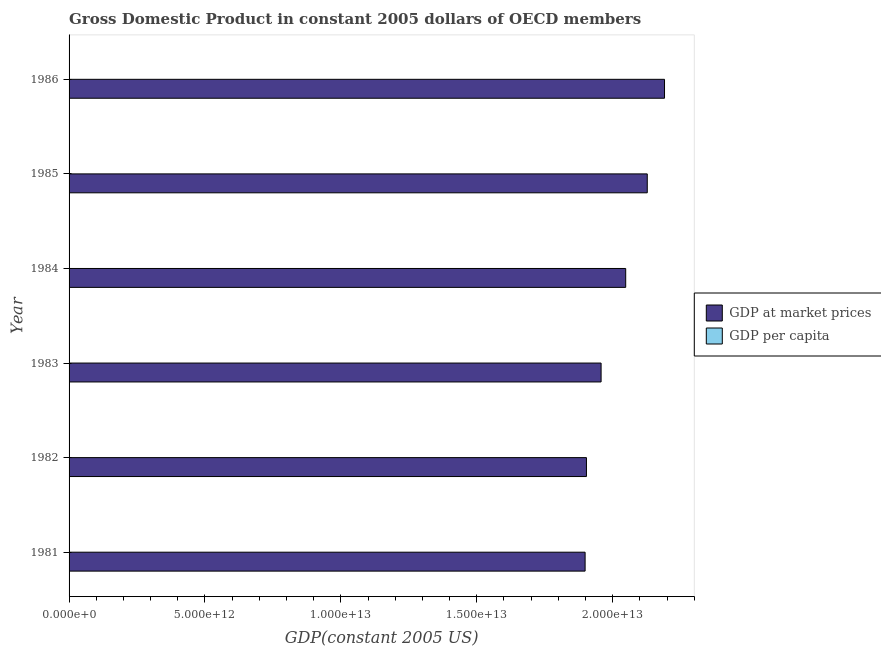How many different coloured bars are there?
Offer a terse response. 2. How many bars are there on the 2nd tick from the bottom?
Ensure brevity in your answer.  2. What is the label of the 3rd group of bars from the top?
Provide a succinct answer. 1984. What is the gdp at market prices in 1982?
Make the answer very short. 1.90e+13. Across all years, what is the maximum gdp at market prices?
Your answer should be compact. 2.19e+13. Across all years, what is the minimum gdp per capita?
Offer a very short reply. 1.90e+04. In which year was the gdp per capita minimum?
Your answer should be very brief. 1982. What is the total gdp per capita in the graph?
Keep it short and to the point. 1.20e+05. What is the difference between the gdp per capita in 1981 and that in 1985?
Offer a very short reply. -1648.86. What is the difference between the gdp at market prices in 1985 and the gdp per capita in 1982?
Give a very brief answer. 2.13e+13. What is the average gdp at market prices per year?
Give a very brief answer. 2.02e+13. In the year 1983, what is the difference between the gdp per capita and gdp at market prices?
Make the answer very short. -1.96e+13. What is the ratio of the gdp at market prices in 1982 to that in 1984?
Provide a short and direct response. 0.93. What is the difference between the highest and the second highest gdp per capita?
Make the answer very short. 455.47. What is the difference between the highest and the lowest gdp at market prices?
Keep it short and to the point. 2.92e+12. In how many years, is the gdp per capita greater than the average gdp per capita taken over all years?
Give a very brief answer. 3. What does the 1st bar from the top in 1981 represents?
Offer a very short reply. GDP per capita. What does the 2nd bar from the bottom in 1983 represents?
Make the answer very short. GDP per capita. Are all the bars in the graph horizontal?
Make the answer very short. Yes. How many years are there in the graph?
Provide a short and direct response. 6. What is the difference between two consecutive major ticks on the X-axis?
Give a very brief answer. 5.00e+12. Are the values on the major ticks of X-axis written in scientific E-notation?
Your answer should be compact. Yes. How are the legend labels stacked?
Make the answer very short. Vertical. What is the title of the graph?
Keep it short and to the point. Gross Domestic Product in constant 2005 dollars of OECD members. What is the label or title of the X-axis?
Your response must be concise. GDP(constant 2005 US). What is the label or title of the Y-axis?
Make the answer very short. Year. What is the GDP(constant 2005 US) of GDP at market prices in 1981?
Provide a succinct answer. 1.90e+13. What is the GDP(constant 2005 US) of GDP per capita in 1981?
Your answer should be compact. 1.91e+04. What is the GDP(constant 2005 US) of GDP at market prices in 1982?
Keep it short and to the point. 1.90e+13. What is the GDP(constant 2005 US) in GDP per capita in 1982?
Keep it short and to the point. 1.90e+04. What is the GDP(constant 2005 US) of GDP at market prices in 1983?
Your response must be concise. 1.96e+13. What is the GDP(constant 2005 US) of GDP per capita in 1983?
Provide a short and direct response. 1.94e+04. What is the GDP(constant 2005 US) of GDP at market prices in 1984?
Ensure brevity in your answer.  2.05e+13. What is the GDP(constant 2005 US) in GDP per capita in 1984?
Your answer should be compact. 2.01e+04. What is the GDP(constant 2005 US) of GDP at market prices in 1985?
Offer a terse response. 2.13e+13. What is the GDP(constant 2005 US) of GDP per capita in 1985?
Your answer should be compact. 2.08e+04. What is the GDP(constant 2005 US) in GDP at market prices in 1986?
Make the answer very short. 2.19e+13. What is the GDP(constant 2005 US) in GDP per capita in 1986?
Provide a short and direct response. 2.12e+04. Across all years, what is the maximum GDP(constant 2005 US) in GDP at market prices?
Provide a succinct answer. 2.19e+13. Across all years, what is the maximum GDP(constant 2005 US) of GDP per capita?
Provide a short and direct response. 2.12e+04. Across all years, what is the minimum GDP(constant 2005 US) in GDP at market prices?
Your answer should be compact. 1.90e+13. Across all years, what is the minimum GDP(constant 2005 US) in GDP per capita?
Provide a succinct answer. 1.90e+04. What is the total GDP(constant 2005 US) of GDP at market prices in the graph?
Your answer should be very brief. 1.21e+14. What is the total GDP(constant 2005 US) of GDP per capita in the graph?
Give a very brief answer. 1.20e+05. What is the difference between the GDP(constant 2005 US) of GDP at market prices in 1981 and that in 1982?
Your answer should be compact. -4.97e+1. What is the difference between the GDP(constant 2005 US) in GDP per capita in 1981 and that in 1982?
Your answer should be very brief. 106.9. What is the difference between the GDP(constant 2005 US) of GDP at market prices in 1981 and that in 1983?
Provide a succinct answer. -5.88e+11. What is the difference between the GDP(constant 2005 US) of GDP per capita in 1981 and that in 1983?
Give a very brief answer. -278.28. What is the difference between the GDP(constant 2005 US) of GDP at market prices in 1981 and that in 1984?
Ensure brevity in your answer.  -1.49e+12. What is the difference between the GDP(constant 2005 US) in GDP per capita in 1981 and that in 1984?
Provide a short and direct response. -1024.64. What is the difference between the GDP(constant 2005 US) in GDP at market prices in 1981 and that in 1985?
Offer a very short reply. -2.29e+12. What is the difference between the GDP(constant 2005 US) of GDP per capita in 1981 and that in 1985?
Provide a short and direct response. -1648.85. What is the difference between the GDP(constant 2005 US) in GDP at market prices in 1981 and that in 1986?
Give a very brief answer. -2.92e+12. What is the difference between the GDP(constant 2005 US) of GDP per capita in 1981 and that in 1986?
Your answer should be compact. -2104.33. What is the difference between the GDP(constant 2005 US) of GDP at market prices in 1982 and that in 1983?
Provide a succinct answer. -5.38e+11. What is the difference between the GDP(constant 2005 US) of GDP per capita in 1982 and that in 1983?
Offer a very short reply. -385.18. What is the difference between the GDP(constant 2005 US) in GDP at market prices in 1982 and that in 1984?
Offer a terse response. -1.44e+12. What is the difference between the GDP(constant 2005 US) in GDP per capita in 1982 and that in 1984?
Ensure brevity in your answer.  -1131.54. What is the difference between the GDP(constant 2005 US) of GDP at market prices in 1982 and that in 1985?
Your answer should be very brief. -2.24e+12. What is the difference between the GDP(constant 2005 US) of GDP per capita in 1982 and that in 1985?
Your response must be concise. -1755.76. What is the difference between the GDP(constant 2005 US) of GDP at market prices in 1982 and that in 1986?
Offer a terse response. -2.87e+12. What is the difference between the GDP(constant 2005 US) of GDP per capita in 1982 and that in 1986?
Make the answer very short. -2211.23. What is the difference between the GDP(constant 2005 US) in GDP at market prices in 1983 and that in 1984?
Provide a succinct answer. -9.05e+11. What is the difference between the GDP(constant 2005 US) in GDP per capita in 1983 and that in 1984?
Your answer should be very brief. -746.36. What is the difference between the GDP(constant 2005 US) of GDP at market prices in 1983 and that in 1985?
Give a very brief answer. -1.70e+12. What is the difference between the GDP(constant 2005 US) in GDP per capita in 1983 and that in 1985?
Your response must be concise. -1370.58. What is the difference between the GDP(constant 2005 US) of GDP at market prices in 1983 and that in 1986?
Ensure brevity in your answer.  -2.33e+12. What is the difference between the GDP(constant 2005 US) of GDP per capita in 1983 and that in 1986?
Your answer should be very brief. -1826.05. What is the difference between the GDP(constant 2005 US) of GDP at market prices in 1984 and that in 1985?
Offer a very short reply. -7.93e+11. What is the difference between the GDP(constant 2005 US) in GDP per capita in 1984 and that in 1985?
Provide a short and direct response. -624.22. What is the difference between the GDP(constant 2005 US) in GDP at market prices in 1984 and that in 1986?
Provide a succinct answer. -1.43e+12. What is the difference between the GDP(constant 2005 US) of GDP per capita in 1984 and that in 1986?
Provide a succinct answer. -1079.69. What is the difference between the GDP(constant 2005 US) in GDP at market prices in 1985 and that in 1986?
Make the answer very short. -6.35e+11. What is the difference between the GDP(constant 2005 US) of GDP per capita in 1985 and that in 1986?
Provide a short and direct response. -455.47. What is the difference between the GDP(constant 2005 US) of GDP at market prices in 1981 and the GDP(constant 2005 US) of GDP per capita in 1982?
Provide a succinct answer. 1.90e+13. What is the difference between the GDP(constant 2005 US) in GDP at market prices in 1981 and the GDP(constant 2005 US) in GDP per capita in 1983?
Give a very brief answer. 1.90e+13. What is the difference between the GDP(constant 2005 US) of GDP at market prices in 1981 and the GDP(constant 2005 US) of GDP per capita in 1984?
Provide a succinct answer. 1.90e+13. What is the difference between the GDP(constant 2005 US) in GDP at market prices in 1981 and the GDP(constant 2005 US) in GDP per capita in 1985?
Your response must be concise. 1.90e+13. What is the difference between the GDP(constant 2005 US) in GDP at market prices in 1981 and the GDP(constant 2005 US) in GDP per capita in 1986?
Your response must be concise. 1.90e+13. What is the difference between the GDP(constant 2005 US) in GDP at market prices in 1982 and the GDP(constant 2005 US) in GDP per capita in 1983?
Provide a short and direct response. 1.90e+13. What is the difference between the GDP(constant 2005 US) of GDP at market prices in 1982 and the GDP(constant 2005 US) of GDP per capita in 1984?
Give a very brief answer. 1.90e+13. What is the difference between the GDP(constant 2005 US) of GDP at market prices in 1982 and the GDP(constant 2005 US) of GDP per capita in 1985?
Keep it short and to the point. 1.90e+13. What is the difference between the GDP(constant 2005 US) in GDP at market prices in 1982 and the GDP(constant 2005 US) in GDP per capita in 1986?
Keep it short and to the point. 1.90e+13. What is the difference between the GDP(constant 2005 US) in GDP at market prices in 1983 and the GDP(constant 2005 US) in GDP per capita in 1984?
Your response must be concise. 1.96e+13. What is the difference between the GDP(constant 2005 US) of GDP at market prices in 1983 and the GDP(constant 2005 US) of GDP per capita in 1985?
Make the answer very short. 1.96e+13. What is the difference between the GDP(constant 2005 US) of GDP at market prices in 1983 and the GDP(constant 2005 US) of GDP per capita in 1986?
Give a very brief answer. 1.96e+13. What is the difference between the GDP(constant 2005 US) of GDP at market prices in 1984 and the GDP(constant 2005 US) of GDP per capita in 1985?
Offer a terse response. 2.05e+13. What is the difference between the GDP(constant 2005 US) of GDP at market prices in 1984 and the GDP(constant 2005 US) of GDP per capita in 1986?
Keep it short and to the point. 2.05e+13. What is the difference between the GDP(constant 2005 US) of GDP at market prices in 1985 and the GDP(constant 2005 US) of GDP per capita in 1986?
Offer a terse response. 2.13e+13. What is the average GDP(constant 2005 US) in GDP at market prices per year?
Your response must be concise. 2.02e+13. What is the average GDP(constant 2005 US) in GDP per capita per year?
Ensure brevity in your answer.  1.99e+04. In the year 1981, what is the difference between the GDP(constant 2005 US) in GDP at market prices and GDP(constant 2005 US) in GDP per capita?
Your response must be concise. 1.90e+13. In the year 1982, what is the difference between the GDP(constant 2005 US) of GDP at market prices and GDP(constant 2005 US) of GDP per capita?
Provide a succinct answer. 1.90e+13. In the year 1983, what is the difference between the GDP(constant 2005 US) in GDP at market prices and GDP(constant 2005 US) in GDP per capita?
Provide a succinct answer. 1.96e+13. In the year 1984, what is the difference between the GDP(constant 2005 US) of GDP at market prices and GDP(constant 2005 US) of GDP per capita?
Provide a short and direct response. 2.05e+13. In the year 1985, what is the difference between the GDP(constant 2005 US) in GDP at market prices and GDP(constant 2005 US) in GDP per capita?
Ensure brevity in your answer.  2.13e+13. In the year 1986, what is the difference between the GDP(constant 2005 US) in GDP at market prices and GDP(constant 2005 US) in GDP per capita?
Make the answer very short. 2.19e+13. What is the ratio of the GDP(constant 2005 US) in GDP per capita in 1981 to that in 1982?
Ensure brevity in your answer.  1.01. What is the ratio of the GDP(constant 2005 US) in GDP per capita in 1981 to that in 1983?
Make the answer very short. 0.99. What is the ratio of the GDP(constant 2005 US) of GDP at market prices in 1981 to that in 1984?
Provide a short and direct response. 0.93. What is the ratio of the GDP(constant 2005 US) of GDP per capita in 1981 to that in 1984?
Offer a very short reply. 0.95. What is the ratio of the GDP(constant 2005 US) in GDP at market prices in 1981 to that in 1985?
Make the answer very short. 0.89. What is the ratio of the GDP(constant 2005 US) of GDP per capita in 1981 to that in 1985?
Keep it short and to the point. 0.92. What is the ratio of the GDP(constant 2005 US) of GDP at market prices in 1981 to that in 1986?
Provide a succinct answer. 0.87. What is the ratio of the GDP(constant 2005 US) in GDP per capita in 1981 to that in 1986?
Give a very brief answer. 0.9. What is the ratio of the GDP(constant 2005 US) in GDP at market prices in 1982 to that in 1983?
Provide a short and direct response. 0.97. What is the ratio of the GDP(constant 2005 US) of GDP per capita in 1982 to that in 1983?
Make the answer very short. 0.98. What is the ratio of the GDP(constant 2005 US) of GDP at market prices in 1982 to that in 1984?
Your answer should be compact. 0.93. What is the ratio of the GDP(constant 2005 US) in GDP per capita in 1982 to that in 1984?
Provide a short and direct response. 0.94. What is the ratio of the GDP(constant 2005 US) of GDP at market prices in 1982 to that in 1985?
Your response must be concise. 0.89. What is the ratio of the GDP(constant 2005 US) of GDP per capita in 1982 to that in 1985?
Offer a terse response. 0.92. What is the ratio of the GDP(constant 2005 US) of GDP at market prices in 1982 to that in 1986?
Ensure brevity in your answer.  0.87. What is the ratio of the GDP(constant 2005 US) in GDP per capita in 1982 to that in 1986?
Keep it short and to the point. 0.9. What is the ratio of the GDP(constant 2005 US) of GDP at market prices in 1983 to that in 1984?
Your response must be concise. 0.96. What is the ratio of the GDP(constant 2005 US) of GDP per capita in 1983 to that in 1984?
Provide a short and direct response. 0.96. What is the ratio of the GDP(constant 2005 US) in GDP at market prices in 1983 to that in 1985?
Your response must be concise. 0.92. What is the ratio of the GDP(constant 2005 US) of GDP per capita in 1983 to that in 1985?
Keep it short and to the point. 0.93. What is the ratio of the GDP(constant 2005 US) in GDP at market prices in 1983 to that in 1986?
Keep it short and to the point. 0.89. What is the ratio of the GDP(constant 2005 US) of GDP per capita in 1983 to that in 1986?
Your answer should be very brief. 0.91. What is the ratio of the GDP(constant 2005 US) of GDP at market prices in 1984 to that in 1985?
Give a very brief answer. 0.96. What is the ratio of the GDP(constant 2005 US) of GDP per capita in 1984 to that in 1985?
Offer a very short reply. 0.97. What is the ratio of the GDP(constant 2005 US) of GDP at market prices in 1984 to that in 1986?
Provide a short and direct response. 0.93. What is the ratio of the GDP(constant 2005 US) of GDP per capita in 1984 to that in 1986?
Offer a very short reply. 0.95. What is the ratio of the GDP(constant 2005 US) in GDP at market prices in 1985 to that in 1986?
Provide a short and direct response. 0.97. What is the ratio of the GDP(constant 2005 US) of GDP per capita in 1985 to that in 1986?
Offer a terse response. 0.98. What is the difference between the highest and the second highest GDP(constant 2005 US) of GDP at market prices?
Offer a terse response. 6.35e+11. What is the difference between the highest and the second highest GDP(constant 2005 US) of GDP per capita?
Offer a very short reply. 455.47. What is the difference between the highest and the lowest GDP(constant 2005 US) of GDP at market prices?
Offer a very short reply. 2.92e+12. What is the difference between the highest and the lowest GDP(constant 2005 US) in GDP per capita?
Give a very brief answer. 2211.23. 